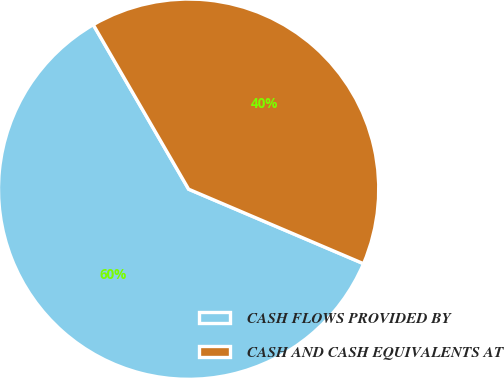Convert chart. <chart><loc_0><loc_0><loc_500><loc_500><pie_chart><fcel>CASH FLOWS PROVIDED BY<fcel>CASH AND CASH EQUIVALENTS AT<nl><fcel>60.23%<fcel>39.77%<nl></chart> 